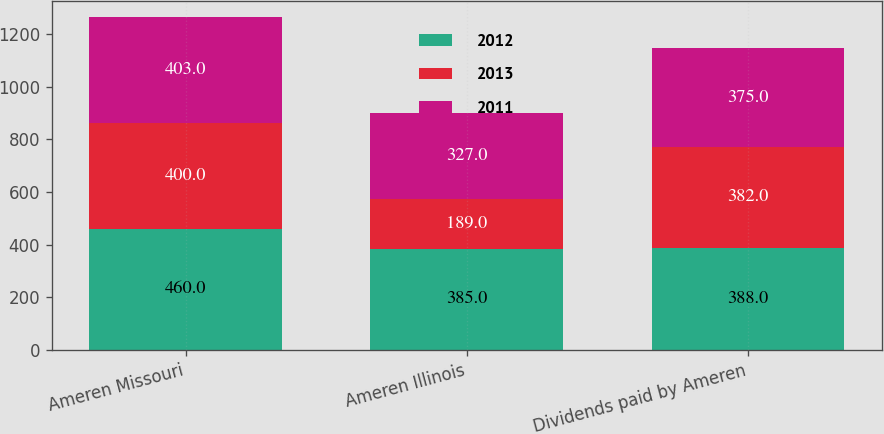Convert chart to OTSL. <chart><loc_0><loc_0><loc_500><loc_500><stacked_bar_chart><ecel><fcel>Ameren Missouri<fcel>Ameren Illinois<fcel>Dividends paid by Ameren<nl><fcel>2012<fcel>460<fcel>385<fcel>388<nl><fcel>2013<fcel>400<fcel>189<fcel>382<nl><fcel>2011<fcel>403<fcel>327<fcel>375<nl></chart> 